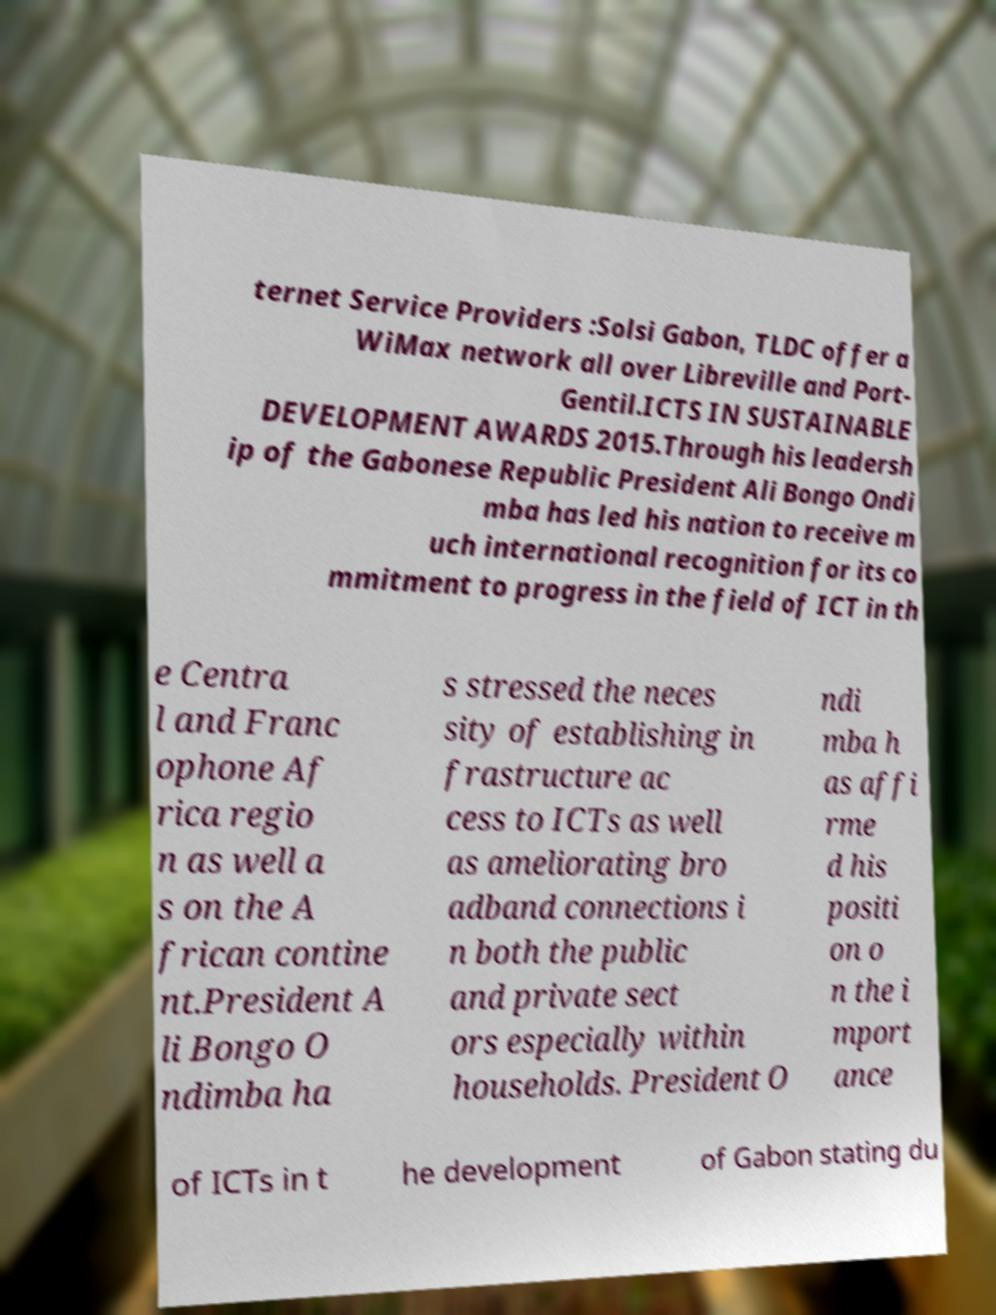What messages or text are displayed in this image? I need them in a readable, typed format. ternet Service Providers :Solsi Gabon, TLDC offer a WiMax network all over Libreville and Port- Gentil.ICTS IN SUSTAINABLE DEVELOPMENT AWARDS 2015.Through his leadersh ip of the Gabonese Republic President Ali Bongo Ondi mba has led his nation to receive m uch international recognition for its co mmitment to progress in the field of ICT in th e Centra l and Franc ophone Af rica regio n as well a s on the A frican contine nt.President A li Bongo O ndimba ha s stressed the neces sity of establishing in frastructure ac cess to ICTs as well as ameliorating bro adband connections i n both the public and private sect ors especially within households. President O ndi mba h as affi rme d his positi on o n the i mport ance of ICTs in t he development of Gabon stating du 